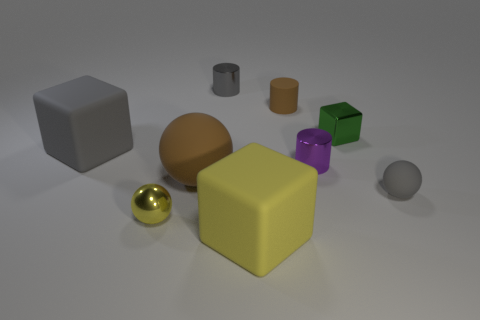How many other objects are there of the same material as the tiny gray sphere?
Make the answer very short. 4. What size is the metallic object that is the same shape as the large gray matte thing?
Make the answer very short. Small. Does the rubber cylinder have the same color as the big sphere?
Your response must be concise. Yes. There is a small thing that is both in front of the brown matte ball and to the left of the tiny brown cylinder; what color is it?
Provide a short and direct response. Yellow. How many things are either gray things right of the small brown matte cylinder or cylinders?
Give a very brief answer. 4. What color is the tiny metallic thing that is the same shape as the big brown matte thing?
Ensure brevity in your answer.  Yellow. Is the shape of the large yellow thing the same as the gray rubber object left of the small metallic block?
Provide a succinct answer. Yes. What number of objects are small things in front of the gray block or gray rubber objects that are left of the metallic sphere?
Make the answer very short. 4. Are there fewer yellow matte cubes that are behind the green thing than small blue objects?
Provide a short and direct response. No. Does the purple object have the same material as the big object that is in front of the small yellow thing?
Your response must be concise. No. 